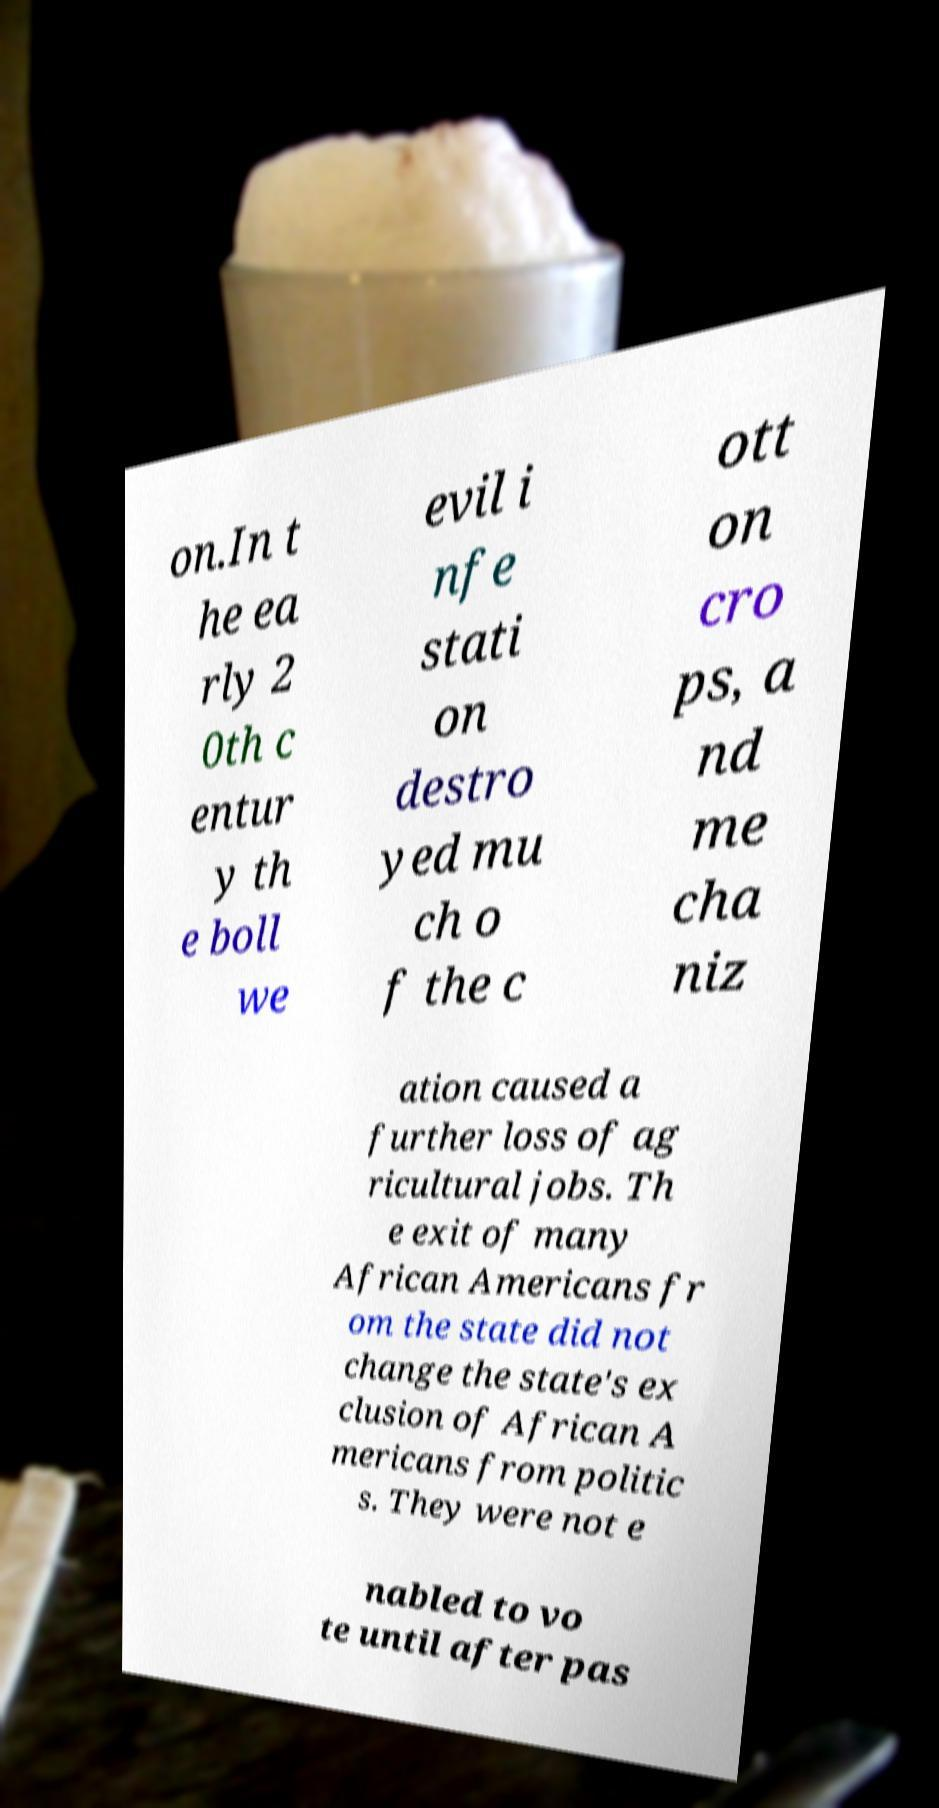I need the written content from this picture converted into text. Can you do that? on.In t he ea rly 2 0th c entur y th e boll we evil i nfe stati on destro yed mu ch o f the c ott on cro ps, a nd me cha niz ation caused a further loss of ag ricultural jobs. Th e exit of many African Americans fr om the state did not change the state's ex clusion of African A mericans from politic s. They were not e nabled to vo te until after pas 